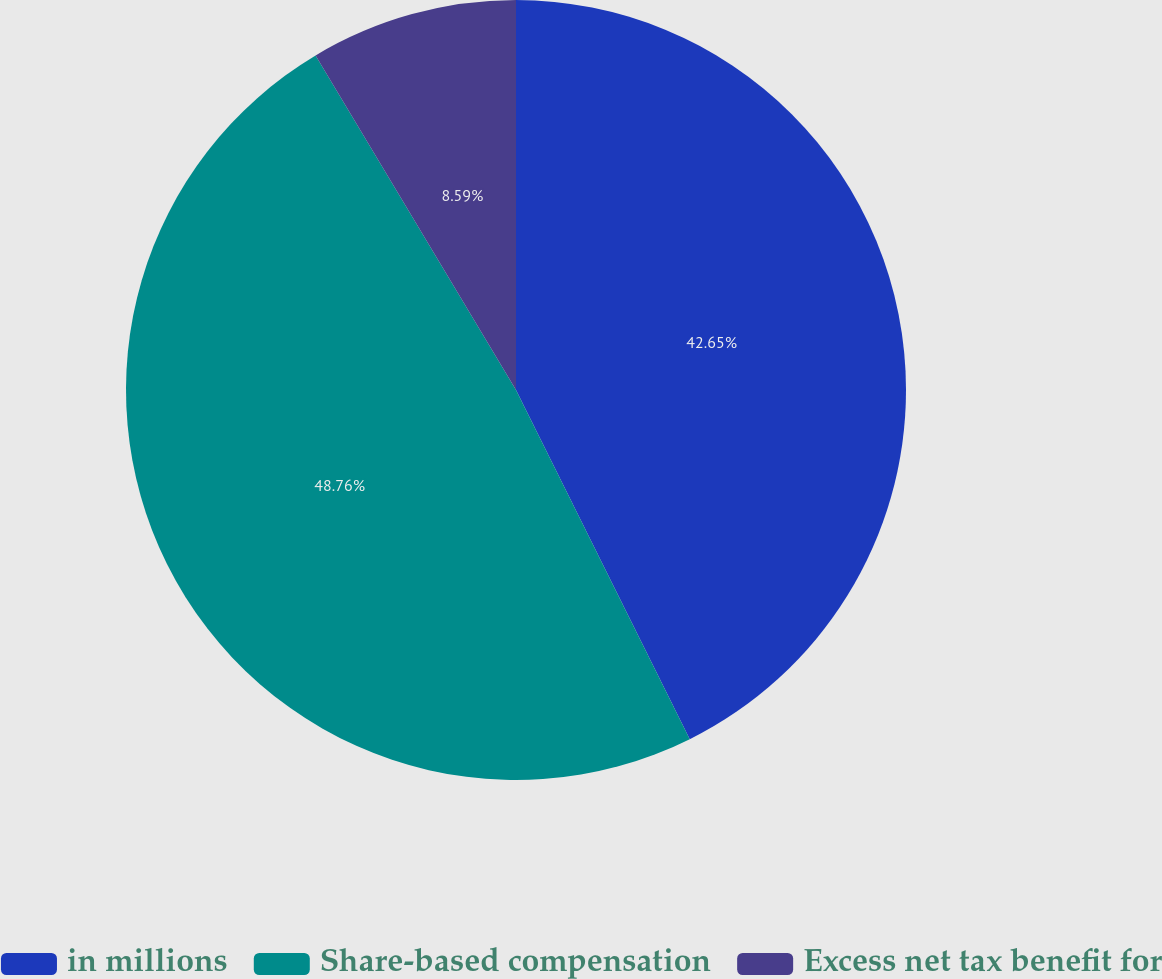Convert chart to OTSL. <chart><loc_0><loc_0><loc_500><loc_500><pie_chart><fcel>in millions<fcel>Share-based compensation<fcel>Excess net tax benefit for<nl><fcel>42.65%<fcel>48.76%<fcel>8.59%<nl></chart> 